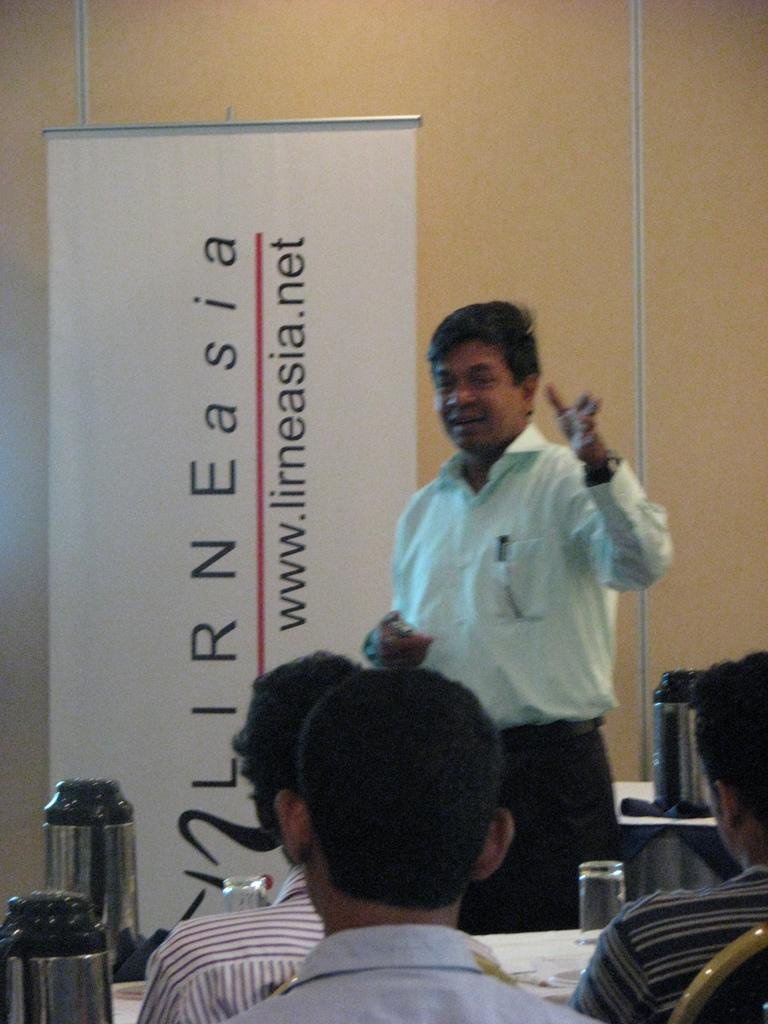<image>
Share a concise interpretation of the image provided. a man stands lecturing in front of a sign with word Asia on it 